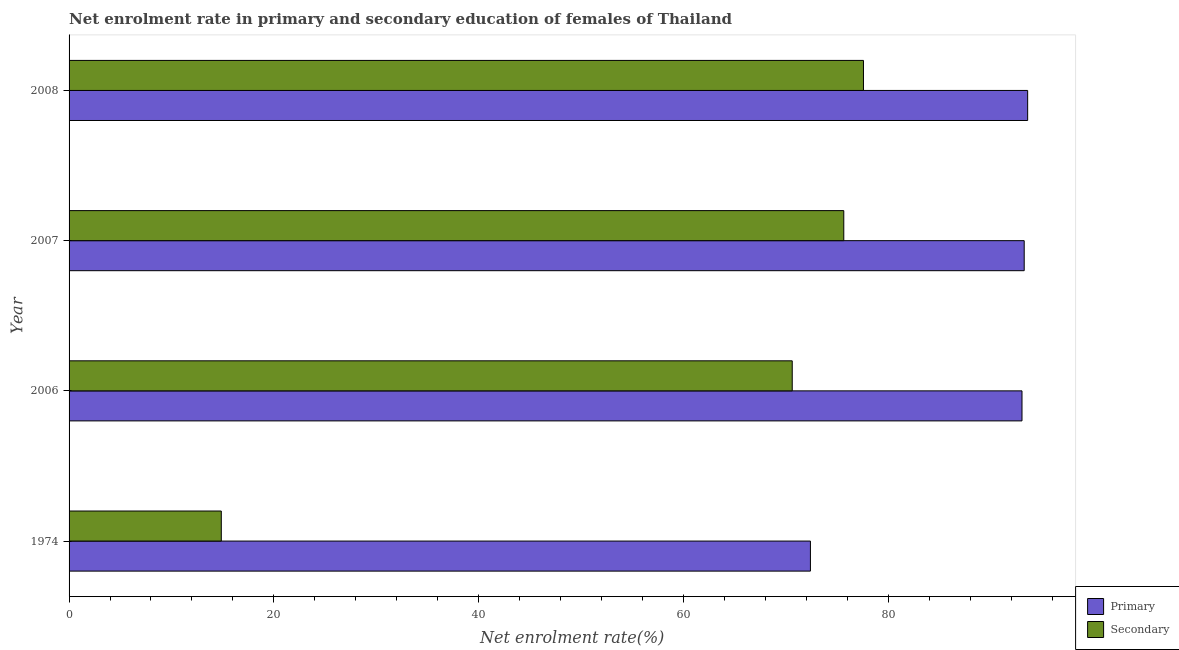How many different coloured bars are there?
Offer a terse response. 2. How many groups of bars are there?
Offer a terse response. 4. Are the number of bars on each tick of the Y-axis equal?
Provide a succinct answer. Yes. How many bars are there on the 3rd tick from the bottom?
Your response must be concise. 2. What is the label of the 4th group of bars from the top?
Your response must be concise. 1974. In how many cases, is the number of bars for a given year not equal to the number of legend labels?
Provide a short and direct response. 0. What is the enrollment rate in secondary education in 2006?
Your response must be concise. 70.63. Across all years, what is the maximum enrollment rate in secondary education?
Give a very brief answer. 77.59. Across all years, what is the minimum enrollment rate in primary education?
Your response must be concise. 72.41. In which year was the enrollment rate in primary education maximum?
Your response must be concise. 2008. In which year was the enrollment rate in secondary education minimum?
Your response must be concise. 1974. What is the total enrollment rate in primary education in the graph?
Offer a very short reply. 352.38. What is the difference between the enrollment rate in primary education in 2007 and that in 2008?
Give a very brief answer. -0.34. What is the difference between the enrollment rate in secondary education in 2006 and the enrollment rate in primary education in 2008?
Offer a very short reply. -22.99. What is the average enrollment rate in secondary education per year?
Ensure brevity in your answer.  59.69. In the year 2006, what is the difference between the enrollment rate in secondary education and enrollment rate in primary education?
Your answer should be compact. -22.44. In how many years, is the enrollment rate in secondary education greater than 88 %?
Provide a short and direct response. 0. Is the difference between the enrollment rate in secondary education in 2006 and 2008 greater than the difference between the enrollment rate in primary education in 2006 and 2008?
Your answer should be very brief. No. What is the difference between the highest and the second highest enrollment rate in primary education?
Offer a very short reply. 0.34. What is the difference between the highest and the lowest enrollment rate in secondary education?
Provide a short and direct response. 62.72. In how many years, is the enrollment rate in primary education greater than the average enrollment rate in primary education taken over all years?
Your response must be concise. 3. Is the sum of the enrollment rate in secondary education in 1974 and 2007 greater than the maximum enrollment rate in primary education across all years?
Give a very brief answer. No. What does the 2nd bar from the top in 2008 represents?
Make the answer very short. Primary. What does the 2nd bar from the bottom in 2008 represents?
Your response must be concise. Secondary. Are all the bars in the graph horizontal?
Provide a succinct answer. Yes. How many years are there in the graph?
Keep it short and to the point. 4. Does the graph contain any zero values?
Ensure brevity in your answer.  No. How many legend labels are there?
Your response must be concise. 2. What is the title of the graph?
Make the answer very short. Net enrolment rate in primary and secondary education of females of Thailand. Does "Register a property" appear as one of the legend labels in the graph?
Ensure brevity in your answer.  No. What is the label or title of the X-axis?
Offer a very short reply. Net enrolment rate(%). What is the label or title of the Y-axis?
Your answer should be compact. Year. What is the Net enrolment rate(%) of Primary in 1974?
Keep it short and to the point. 72.41. What is the Net enrolment rate(%) of Secondary in 1974?
Make the answer very short. 14.87. What is the Net enrolment rate(%) in Primary in 2006?
Your response must be concise. 93.07. What is the Net enrolment rate(%) of Secondary in 2006?
Keep it short and to the point. 70.63. What is the Net enrolment rate(%) in Primary in 2007?
Offer a very short reply. 93.28. What is the Net enrolment rate(%) in Secondary in 2007?
Offer a very short reply. 75.66. What is the Net enrolment rate(%) of Primary in 2008?
Provide a short and direct response. 93.62. What is the Net enrolment rate(%) in Secondary in 2008?
Your response must be concise. 77.59. Across all years, what is the maximum Net enrolment rate(%) of Primary?
Your response must be concise. 93.62. Across all years, what is the maximum Net enrolment rate(%) in Secondary?
Your answer should be compact. 77.59. Across all years, what is the minimum Net enrolment rate(%) in Primary?
Your answer should be very brief. 72.41. Across all years, what is the minimum Net enrolment rate(%) in Secondary?
Ensure brevity in your answer.  14.87. What is the total Net enrolment rate(%) of Primary in the graph?
Make the answer very short. 352.38. What is the total Net enrolment rate(%) of Secondary in the graph?
Your response must be concise. 238.75. What is the difference between the Net enrolment rate(%) of Primary in 1974 and that in 2006?
Provide a short and direct response. -20.66. What is the difference between the Net enrolment rate(%) in Secondary in 1974 and that in 2006?
Ensure brevity in your answer.  -55.76. What is the difference between the Net enrolment rate(%) in Primary in 1974 and that in 2007?
Your answer should be compact. -20.88. What is the difference between the Net enrolment rate(%) of Secondary in 1974 and that in 2007?
Ensure brevity in your answer.  -60.8. What is the difference between the Net enrolment rate(%) in Primary in 1974 and that in 2008?
Your response must be concise. -21.22. What is the difference between the Net enrolment rate(%) of Secondary in 1974 and that in 2008?
Ensure brevity in your answer.  -62.72. What is the difference between the Net enrolment rate(%) of Primary in 2006 and that in 2007?
Your response must be concise. -0.22. What is the difference between the Net enrolment rate(%) of Secondary in 2006 and that in 2007?
Offer a terse response. -5.03. What is the difference between the Net enrolment rate(%) in Primary in 2006 and that in 2008?
Keep it short and to the point. -0.55. What is the difference between the Net enrolment rate(%) in Secondary in 2006 and that in 2008?
Your response must be concise. -6.96. What is the difference between the Net enrolment rate(%) of Primary in 2007 and that in 2008?
Your answer should be compact. -0.34. What is the difference between the Net enrolment rate(%) of Secondary in 2007 and that in 2008?
Offer a terse response. -1.92. What is the difference between the Net enrolment rate(%) in Primary in 1974 and the Net enrolment rate(%) in Secondary in 2006?
Provide a short and direct response. 1.78. What is the difference between the Net enrolment rate(%) in Primary in 1974 and the Net enrolment rate(%) in Secondary in 2007?
Your answer should be compact. -3.26. What is the difference between the Net enrolment rate(%) in Primary in 1974 and the Net enrolment rate(%) in Secondary in 2008?
Make the answer very short. -5.18. What is the difference between the Net enrolment rate(%) in Primary in 2006 and the Net enrolment rate(%) in Secondary in 2007?
Ensure brevity in your answer.  17.41. What is the difference between the Net enrolment rate(%) in Primary in 2006 and the Net enrolment rate(%) in Secondary in 2008?
Provide a short and direct response. 15.48. What is the difference between the Net enrolment rate(%) of Primary in 2007 and the Net enrolment rate(%) of Secondary in 2008?
Your answer should be very brief. 15.7. What is the average Net enrolment rate(%) in Primary per year?
Your answer should be very brief. 88.1. What is the average Net enrolment rate(%) of Secondary per year?
Ensure brevity in your answer.  59.69. In the year 1974, what is the difference between the Net enrolment rate(%) of Primary and Net enrolment rate(%) of Secondary?
Keep it short and to the point. 57.54. In the year 2006, what is the difference between the Net enrolment rate(%) of Primary and Net enrolment rate(%) of Secondary?
Provide a succinct answer. 22.44. In the year 2007, what is the difference between the Net enrolment rate(%) in Primary and Net enrolment rate(%) in Secondary?
Make the answer very short. 17.62. In the year 2008, what is the difference between the Net enrolment rate(%) of Primary and Net enrolment rate(%) of Secondary?
Give a very brief answer. 16.04. What is the ratio of the Net enrolment rate(%) in Primary in 1974 to that in 2006?
Make the answer very short. 0.78. What is the ratio of the Net enrolment rate(%) of Secondary in 1974 to that in 2006?
Ensure brevity in your answer.  0.21. What is the ratio of the Net enrolment rate(%) in Primary in 1974 to that in 2007?
Ensure brevity in your answer.  0.78. What is the ratio of the Net enrolment rate(%) of Secondary in 1974 to that in 2007?
Provide a succinct answer. 0.2. What is the ratio of the Net enrolment rate(%) in Primary in 1974 to that in 2008?
Offer a terse response. 0.77. What is the ratio of the Net enrolment rate(%) of Secondary in 1974 to that in 2008?
Provide a short and direct response. 0.19. What is the ratio of the Net enrolment rate(%) of Secondary in 2006 to that in 2007?
Make the answer very short. 0.93. What is the ratio of the Net enrolment rate(%) in Secondary in 2006 to that in 2008?
Ensure brevity in your answer.  0.91. What is the ratio of the Net enrolment rate(%) in Secondary in 2007 to that in 2008?
Your answer should be very brief. 0.98. What is the difference between the highest and the second highest Net enrolment rate(%) in Primary?
Offer a terse response. 0.34. What is the difference between the highest and the second highest Net enrolment rate(%) of Secondary?
Make the answer very short. 1.92. What is the difference between the highest and the lowest Net enrolment rate(%) in Primary?
Offer a very short reply. 21.22. What is the difference between the highest and the lowest Net enrolment rate(%) in Secondary?
Make the answer very short. 62.72. 